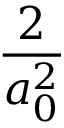<formula> <loc_0><loc_0><loc_500><loc_500>\frac { 2 } { a _ { 0 } ^ { 2 } }</formula> 